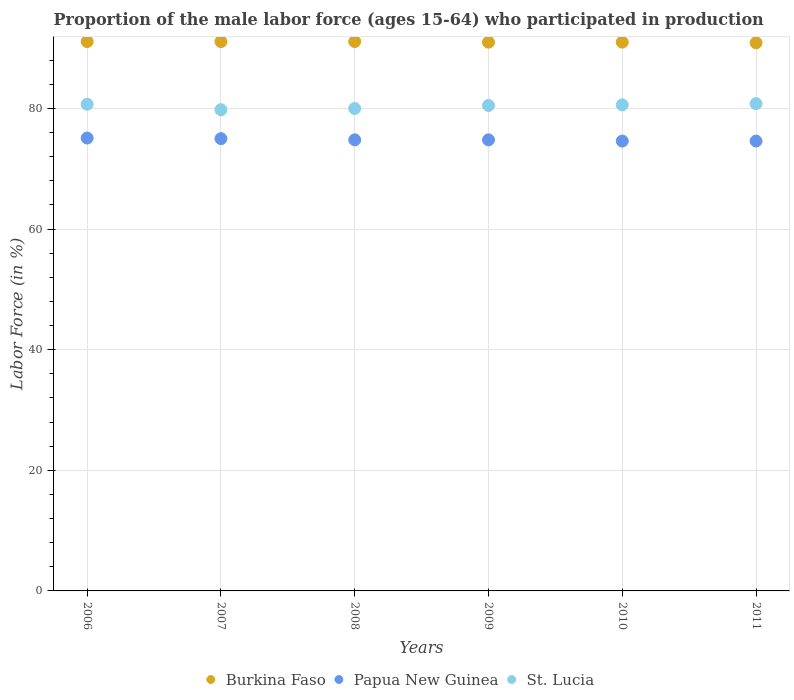Is the number of dotlines equal to the number of legend labels?
Give a very brief answer. Yes. What is the proportion of the male labor force who participated in production in Burkina Faso in 2008?
Provide a succinct answer. 91.1. Across all years, what is the maximum proportion of the male labor force who participated in production in Burkina Faso?
Make the answer very short. 91.1. Across all years, what is the minimum proportion of the male labor force who participated in production in Papua New Guinea?
Ensure brevity in your answer.  74.6. In which year was the proportion of the male labor force who participated in production in Papua New Guinea maximum?
Give a very brief answer. 2006. In which year was the proportion of the male labor force who participated in production in St. Lucia minimum?
Give a very brief answer. 2007. What is the total proportion of the male labor force who participated in production in St. Lucia in the graph?
Your answer should be compact. 482.4. What is the difference between the proportion of the male labor force who participated in production in Burkina Faso in 2009 and that in 2010?
Give a very brief answer. 0. What is the difference between the proportion of the male labor force who participated in production in Papua New Guinea in 2008 and the proportion of the male labor force who participated in production in St. Lucia in 2009?
Offer a very short reply. -5.7. What is the average proportion of the male labor force who participated in production in St. Lucia per year?
Your answer should be compact. 80.4. In the year 2008, what is the difference between the proportion of the male labor force who participated in production in St. Lucia and proportion of the male labor force who participated in production in Burkina Faso?
Provide a succinct answer. -11.1. In how many years, is the proportion of the male labor force who participated in production in Burkina Faso greater than 56 %?
Provide a succinct answer. 6. What is the ratio of the proportion of the male labor force who participated in production in Burkina Faso in 2006 to that in 2009?
Your response must be concise. 1. Is the proportion of the male labor force who participated in production in Burkina Faso in 2008 less than that in 2009?
Offer a terse response. No. What is the difference between the highest and the second highest proportion of the male labor force who participated in production in Burkina Faso?
Ensure brevity in your answer.  0. What is the difference between the highest and the lowest proportion of the male labor force who participated in production in St. Lucia?
Your answer should be compact. 1. In how many years, is the proportion of the male labor force who participated in production in St. Lucia greater than the average proportion of the male labor force who participated in production in St. Lucia taken over all years?
Offer a very short reply. 4. Does the proportion of the male labor force who participated in production in Papua New Guinea monotonically increase over the years?
Offer a very short reply. No. Is the proportion of the male labor force who participated in production in St. Lucia strictly less than the proportion of the male labor force who participated in production in Papua New Guinea over the years?
Provide a succinct answer. No. What is the difference between two consecutive major ticks on the Y-axis?
Give a very brief answer. 20. Does the graph contain any zero values?
Your response must be concise. No. Does the graph contain grids?
Your answer should be compact. Yes. How are the legend labels stacked?
Give a very brief answer. Horizontal. What is the title of the graph?
Make the answer very short. Proportion of the male labor force (ages 15-64) who participated in production. Does "Mauritius" appear as one of the legend labels in the graph?
Your answer should be very brief. No. What is the label or title of the X-axis?
Provide a succinct answer. Years. What is the Labor Force (in %) of Burkina Faso in 2006?
Offer a terse response. 91.1. What is the Labor Force (in %) of Papua New Guinea in 2006?
Your response must be concise. 75.1. What is the Labor Force (in %) of St. Lucia in 2006?
Make the answer very short. 80.7. What is the Labor Force (in %) of Burkina Faso in 2007?
Keep it short and to the point. 91.1. What is the Labor Force (in %) of Papua New Guinea in 2007?
Your response must be concise. 75. What is the Labor Force (in %) in St. Lucia in 2007?
Make the answer very short. 79.8. What is the Labor Force (in %) in Burkina Faso in 2008?
Ensure brevity in your answer.  91.1. What is the Labor Force (in %) in Papua New Guinea in 2008?
Your response must be concise. 74.8. What is the Labor Force (in %) of St. Lucia in 2008?
Keep it short and to the point. 80. What is the Labor Force (in %) in Burkina Faso in 2009?
Your response must be concise. 91. What is the Labor Force (in %) of Papua New Guinea in 2009?
Offer a terse response. 74.8. What is the Labor Force (in %) in St. Lucia in 2009?
Your answer should be very brief. 80.5. What is the Labor Force (in %) of Burkina Faso in 2010?
Keep it short and to the point. 91. What is the Labor Force (in %) in Papua New Guinea in 2010?
Offer a very short reply. 74.6. What is the Labor Force (in %) in St. Lucia in 2010?
Make the answer very short. 80.6. What is the Labor Force (in %) of Burkina Faso in 2011?
Give a very brief answer. 90.9. What is the Labor Force (in %) in Papua New Guinea in 2011?
Offer a very short reply. 74.6. What is the Labor Force (in %) of St. Lucia in 2011?
Provide a succinct answer. 80.8. Across all years, what is the maximum Labor Force (in %) in Burkina Faso?
Offer a terse response. 91.1. Across all years, what is the maximum Labor Force (in %) of Papua New Guinea?
Keep it short and to the point. 75.1. Across all years, what is the maximum Labor Force (in %) of St. Lucia?
Provide a succinct answer. 80.8. Across all years, what is the minimum Labor Force (in %) of Burkina Faso?
Offer a terse response. 90.9. Across all years, what is the minimum Labor Force (in %) of Papua New Guinea?
Your answer should be compact. 74.6. Across all years, what is the minimum Labor Force (in %) of St. Lucia?
Give a very brief answer. 79.8. What is the total Labor Force (in %) in Burkina Faso in the graph?
Ensure brevity in your answer.  546.2. What is the total Labor Force (in %) of Papua New Guinea in the graph?
Your answer should be compact. 448.9. What is the total Labor Force (in %) in St. Lucia in the graph?
Your response must be concise. 482.4. What is the difference between the Labor Force (in %) in Burkina Faso in 2006 and that in 2007?
Offer a very short reply. 0. What is the difference between the Labor Force (in %) in Papua New Guinea in 2006 and that in 2007?
Your answer should be very brief. 0.1. What is the difference between the Labor Force (in %) of St. Lucia in 2006 and that in 2007?
Your answer should be compact. 0.9. What is the difference between the Labor Force (in %) of Burkina Faso in 2006 and that in 2009?
Provide a short and direct response. 0.1. What is the difference between the Labor Force (in %) of St. Lucia in 2006 and that in 2009?
Your response must be concise. 0.2. What is the difference between the Labor Force (in %) in Papua New Guinea in 2006 and that in 2010?
Offer a very short reply. 0.5. What is the difference between the Labor Force (in %) of Burkina Faso in 2007 and that in 2008?
Offer a very short reply. 0. What is the difference between the Labor Force (in %) in St. Lucia in 2007 and that in 2008?
Offer a terse response. -0.2. What is the difference between the Labor Force (in %) of St. Lucia in 2007 and that in 2009?
Ensure brevity in your answer.  -0.7. What is the difference between the Labor Force (in %) in Burkina Faso in 2007 and that in 2010?
Keep it short and to the point. 0.1. What is the difference between the Labor Force (in %) of Papua New Guinea in 2007 and that in 2010?
Your answer should be very brief. 0.4. What is the difference between the Labor Force (in %) in St. Lucia in 2007 and that in 2010?
Ensure brevity in your answer.  -0.8. What is the difference between the Labor Force (in %) of Burkina Faso in 2007 and that in 2011?
Provide a short and direct response. 0.2. What is the difference between the Labor Force (in %) in Papua New Guinea in 2007 and that in 2011?
Offer a very short reply. 0.4. What is the difference between the Labor Force (in %) in Burkina Faso in 2008 and that in 2010?
Offer a terse response. 0.1. What is the difference between the Labor Force (in %) in Papua New Guinea in 2008 and that in 2011?
Keep it short and to the point. 0.2. What is the difference between the Labor Force (in %) of St. Lucia in 2008 and that in 2011?
Offer a terse response. -0.8. What is the difference between the Labor Force (in %) in Burkina Faso in 2009 and that in 2010?
Offer a terse response. 0. What is the difference between the Labor Force (in %) of Papua New Guinea in 2009 and that in 2010?
Provide a succinct answer. 0.2. What is the difference between the Labor Force (in %) of St. Lucia in 2009 and that in 2010?
Keep it short and to the point. -0.1. What is the difference between the Labor Force (in %) in Burkina Faso in 2009 and that in 2011?
Give a very brief answer. 0.1. What is the difference between the Labor Force (in %) of St. Lucia in 2009 and that in 2011?
Provide a short and direct response. -0.3. What is the difference between the Labor Force (in %) of Burkina Faso in 2006 and the Labor Force (in %) of Papua New Guinea in 2007?
Provide a short and direct response. 16.1. What is the difference between the Labor Force (in %) of Burkina Faso in 2006 and the Labor Force (in %) of St. Lucia in 2007?
Provide a short and direct response. 11.3. What is the difference between the Labor Force (in %) of Burkina Faso in 2006 and the Labor Force (in %) of Papua New Guinea in 2008?
Ensure brevity in your answer.  16.3. What is the difference between the Labor Force (in %) in Burkina Faso in 2006 and the Labor Force (in %) in St. Lucia in 2008?
Your response must be concise. 11.1. What is the difference between the Labor Force (in %) in Papua New Guinea in 2006 and the Labor Force (in %) in St. Lucia in 2008?
Provide a succinct answer. -4.9. What is the difference between the Labor Force (in %) in Burkina Faso in 2006 and the Labor Force (in %) in St. Lucia in 2009?
Keep it short and to the point. 10.6. What is the difference between the Labor Force (in %) in Burkina Faso in 2006 and the Labor Force (in %) in Papua New Guinea in 2010?
Your answer should be compact. 16.5. What is the difference between the Labor Force (in %) of Burkina Faso in 2006 and the Labor Force (in %) of St. Lucia in 2010?
Give a very brief answer. 10.5. What is the difference between the Labor Force (in %) of Burkina Faso in 2006 and the Labor Force (in %) of St. Lucia in 2011?
Offer a terse response. 10.3. What is the difference between the Labor Force (in %) in Burkina Faso in 2007 and the Labor Force (in %) in St. Lucia in 2008?
Your response must be concise. 11.1. What is the difference between the Labor Force (in %) of Burkina Faso in 2007 and the Labor Force (in %) of St. Lucia in 2009?
Ensure brevity in your answer.  10.6. What is the difference between the Labor Force (in %) in Papua New Guinea in 2007 and the Labor Force (in %) in St. Lucia in 2010?
Your answer should be very brief. -5.6. What is the difference between the Labor Force (in %) of Papua New Guinea in 2007 and the Labor Force (in %) of St. Lucia in 2011?
Offer a terse response. -5.8. What is the difference between the Labor Force (in %) of Papua New Guinea in 2008 and the Labor Force (in %) of St. Lucia in 2009?
Your response must be concise. -5.7. What is the difference between the Labor Force (in %) of Burkina Faso in 2008 and the Labor Force (in %) of Papua New Guinea in 2011?
Provide a short and direct response. 16.5. What is the difference between the Labor Force (in %) of Burkina Faso in 2008 and the Labor Force (in %) of St. Lucia in 2011?
Ensure brevity in your answer.  10.3. What is the difference between the Labor Force (in %) in Papua New Guinea in 2008 and the Labor Force (in %) in St. Lucia in 2011?
Offer a very short reply. -6. What is the difference between the Labor Force (in %) of Burkina Faso in 2009 and the Labor Force (in %) of St. Lucia in 2010?
Ensure brevity in your answer.  10.4. What is the difference between the Labor Force (in %) of Burkina Faso in 2009 and the Labor Force (in %) of Papua New Guinea in 2011?
Provide a short and direct response. 16.4. What is the difference between the Labor Force (in %) of Burkina Faso in 2009 and the Labor Force (in %) of St. Lucia in 2011?
Keep it short and to the point. 10.2. What is the difference between the Labor Force (in %) in Papua New Guinea in 2009 and the Labor Force (in %) in St. Lucia in 2011?
Ensure brevity in your answer.  -6. What is the difference between the Labor Force (in %) of Papua New Guinea in 2010 and the Labor Force (in %) of St. Lucia in 2011?
Ensure brevity in your answer.  -6.2. What is the average Labor Force (in %) of Burkina Faso per year?
Your response must be concise. 91.03. What is the average Labor Force (in %) of Papua New Guinea per year?
Offer a very short reply. 74.82. What is the average Labor Force (in %) of St. Lucia per year?
Offer a terse response. 80.4. In the year 2006, what is the difference between the Labor Force (in %) in Burkina Faso and Labor Force (in %) in St. Lucia?
Offer a terse response. 10.4. In the year 2006, what is the difference between the Labor Force (in %) in Papua New Guinea and Labor Force (in %) in St. Lucia?
Offer a terse response. -5.6. In the year 2007, what is the difference between the Labor Force (in %) of Burkina Faso and Labor Force (in %) of Papua New Guinea?
Ensure brevity in your answer.  16.1. In the year 2009, what is the difference between the Labor Force (in %) of Burkina Faso and Labor Force (in %) of St. Lucia?
Your answer should be compact. 10.5. In the year 2009, what is the difference between the Labor Force (in %) of Papua New Guinea and Labor Force (in %) of St. Lucia?
Make the answer very short. -5.7. In the year 2010, what is the difference between the Labor Force (in %) of Burkina Faso and Labor Force (in %) of St. Lucia?
Your response must be concise. 10.4. In the year 2010, what is the difference between the Labor Force (in %) in Papua New Guinea and Labor Force (in %) in St. Lucia?
Your answer should be compact. -6. What is the ratio of the Labor Force (in %) in Papua New Guinea in 2006 to that in 2007?
Your response must be concise. 1. What is the ratio of the Labor Force (in %) in St. Lucia in 2006 to that in 2007?
Ensure brevity in your answer.  1.01. What is the ratio of the Labor Force (in %) of St. Lucia in 2006 to that in 2008?
Keep it short and to the point. 1.01. What is the ratio of the Labor Force (in %) in Papua New Guinea in 2006 to that in 2009?
Offer a very short reply. 1. What is the ratio of the Labor Force (in %) in St. Lucia in 2006 to that in 2010?
Your response must be concise. 1. What is the ratio of the Labor Force (in %) of Burkina Faso in 2006 to that in 2011?
Make the answer very short. 1. What is the ratio of the Labor Force (in %) in St. Lucia in 2006 to that in 2011?
Give a very brief answer. 1. What is the ratio of the Labor Force (in %) of St. Lucia in 2007 to that in 2008?
Offer a terse response. 1. What is the ratio of the Labor Force (in %) of Papua New Guinea in 2007 to that in 2009?
Keep it short and to the point. 1. What is the ratio of the Labor Force (in %) of Burkina Faso in 2007 to that in 2010?
Give a very brief answer. 1. What is the ratio of the Labor Force (in %) of Papua New Guinea in 2007 to that in 2010?
Offer a terse response. 1.01. What is the ratio of the Labor Force (in %) of Burkina Faso in 2007 to that in 2011?
Provide a short and direct response. 1. What is the ratio of the Labor Force (in %) in Papua New Guinea in 2007 to that in 2011?
Keep it short and to the point. 1.01. What is the ratio of the Labor Force (in %) in St. Lucia in 2007 to that in 2011?
Give a very brief answer. 0.99. What is the ratio of the Labor Force (in %) in Papua New Guinea in 2008 to that in 2009?
Make the answer very short. 1. What is the ratio of the Labor Force (in %) of Burkina Faso in 2008 to that in 2010?
Ensure brevity in your answer.  1. What is the ratio of the Labor Force (in %) in Papua New Guinea in 2008 to that in 2010?
Your answer should be very brief. 1. What is the ratio of the Labor Force (in %) in Burkina Faso in 2008 to that in 2011?
Your answer should be compact. 1. What is the ratio of the Labor Force (in %) of Papua New Guinea in 2008 to that in 2011?
Your answer should be compact. 1. What is the ratio of the Labor Force (in %) of St. Lucia in 2008 to that in 2011?
Your answer should be very brief. 0.99. What is the ratio of the Labor Force (in %) of Burkina Faso in 2009 to that in 2010?
Provide a short and direct response. 1. What is the ratio of the Labor Force (in %) of Papua New Guinea in 2009 to that in 2010?
Offer a terse response. 1. What is the ratio of the Labor Force (in %) of Papua New Guinea in 2010 to that in 2011?
Provide a succinct answer. 1. What is the ratio of the Labor Force (in %) of St. Lucia in 2010 to that in 2011?
Your answer should be compact. 1. What is the difference between the highest and the lowest Labor Force (in %) of St. Lucia?
Keep it short and to the point. 1. 